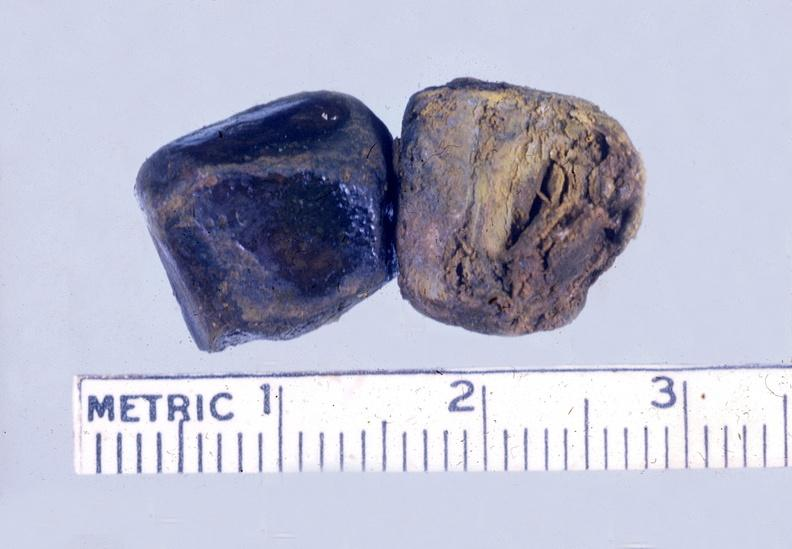does this image show gall bladder, gall stones mixed?
Answer the question using a single word or phrase. Yes 